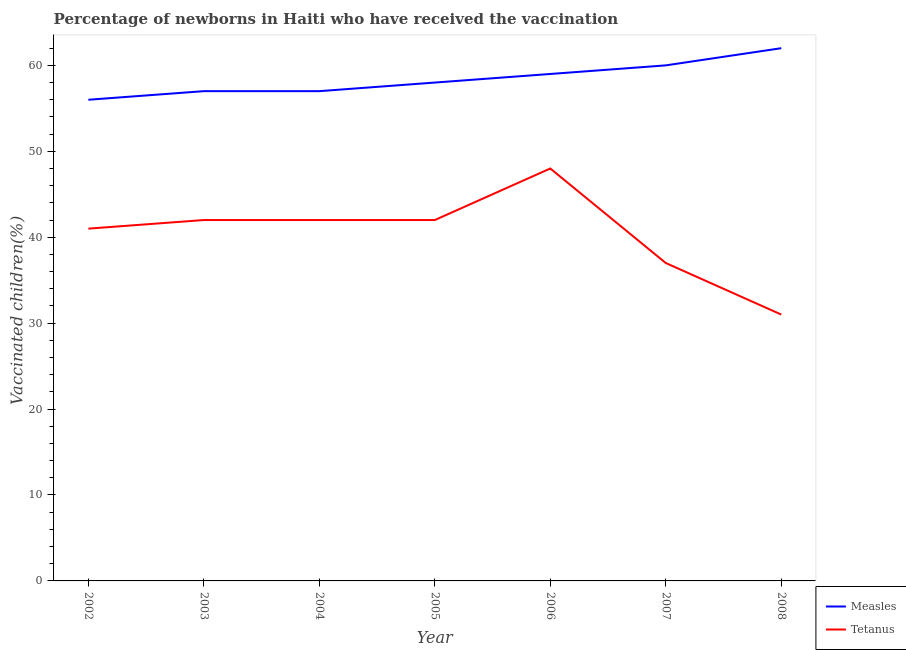How many different coloured lines are there?
Keep it short and to the point. 2. Does the line corresponding to percentage of newborns who received vaccination for measles intersect with the line corresponding to percentage of newborns who received vaccination for tetanus?
Offer a very short reply. No. What is the percentage of newborns who received vaccination for tetanus in 2002?
Your response must be concise. 41. Across all years, what is the maximum percentage of newborns who received vaccination for measles?
Give a very brief answer. 62. Across all years, what is the minimum percentage of newborns who received vaccination for measles?
Make the answer very short. 56. In which year was the percentage of newborns who received vaccination for measles minimum?
Provide a succinct answer. 2002. What is the total percentage of newborns who received vaccination for measles in the graph?
Give a very brief answer. 409. What is the difference between the percentage of newborns who received vaccination for measles in 2002 and that in 2006?
Your response must be concise. -3. What is the difference between the percentage of newborns who received vaccination for measles in 2004 and the percentage of newborns who received vaccination for tetanus in 2003?
Ensure brevity in your answer.  15. What is the average percentage of newborns who received vaccination for tetanus per year?
Offer a very short reply. 40.43. In the year 2002, what is the difference between the percentage of newborns who received vaccination for measles and percentage of newborns who received vaccination for tetanus?
Ensure brevity in your answer.  15. In how many years, is the percentage of newborns who received vaccination for measles greater than 22 %?
Make the answer very short. 7. What is the ratio of the percentage of newborns who received vaccination for tetanus in 2003 to that in 2004?
Offer a very short reply. 1. Is the percentage of newborns who received vaccination for measles in 2003 less than that in 2008?
Your answer should be compact. Yes. Is the difference between the percentage of newborns who received vaccination for tetanus in 2002 and 2007 greater than the difference between the percentage of newborns who received vaccination for measles in 2002 and 2007?
Make the answer very short. Yes. What is the difference between the highest and the lowest percentage of newborns who received vaccination for tetanus?
Give a very brief answer. 17. In how many years, is the percentage of newborns who received vaccination for measles greater than the average percentage of newborns who received vaccination for measles taken over all years?
Your response must be concise. 3. Is the sum of the percentage of newborns who received vaccination for tetanus in 2003 and 2005 greater than the maximum percentage of newborns who received vaccination for measles across all years?
Ensure brevity in your answer.  Yes. Does the percentage of newborns who received vaccination for measles monotonically increase over the years?
Offer a terse response. No. Is the percentage of newborns who received vaccination for measles strictly greater than the percentage of newborns who received vaccination for tetanus over the years?
Make the answer very short. Yes. How many lines are there?
Your response must be concise. 2. How many years are there in the graph?
Offer a very short reply. 7. Does the graph contain any zero values?
Offer a very short reply. No. How many legend labels are there?
Offer a terse response. 2. What is the title of the graph?
Your response must be concise. Percentage of newborns in Haiti who have received the vaccination. What is the label or title of the Y-axis?
Give a very brief answer. Vaccinated children(%)
. What is the Vaccinated children(%)
 in Measles in 2002?
Make the answer very short. 56. What is the Vaccinated children(%)
 of Tetanus in 2002?
Offer a terse response. 41. What is the Vaccinated children(%)
 in Measles in 2004?
Offer a very short reply. 57. What is the Vaccinated children(%)
 in Tetanus in 2004?
Keep it short and to the point. 42. What is the Vaccinated children(%)
 of Measles in 2005?
Offer a very short reply. 58. What is the Vaccinated children(%)
 in Tetanus in 2005?
Ensure brevity in your answer.  42. What is the Vaccinated children(%)
 of Tetanus in 2006?
Offer a very short reply. 48. What is the Vaccinated children(%)
 in Measles in 2007?
Offer a terse response. 60. What is the Vaccinated children(%)
 in Tetanus in 2007?
Give a very brief answer. 37. Across all years, what is the minimum Vaccinated children(%)
 of Measles?
Provide a short and direct response. 56. What is the total Vaccinated children(%)
 in Measles in the graph?
Keep it short and to the point. 409. What is the total Vaccinated children(%)
 in Tetanus in the graph?
Provide a succinct answer. 283. What is the difference between the Vaccinated children(%)
 in Tetanus in 2002 and that in 2003?
Make the answer very short. -1. What is the difference between the Vaccinated children(%)
 in Measles in 2002 and that in 2004?
Your answer should be compact. -1. What is the difference between the Vaccinated children(%)
 of Tetanus in 2002 and that in 2005?
Keep it short and to the point. -1. What is the difference between the Vaccinated children(%)
 of Tetanus in 2002 and that in 2006?
Keep it short and to the point. -7. What is the difference between the Vaccinated children(%)
 of Tetanus in 2002 and that in 2007?
Make the answer very short. 4. What is the difference between the Vaccinated children(%)
 in Measles in 2002 and that in 2008?
Provide a short and direct response. -6. What is the difference between the Vaccinated children(%)
 in Measles in 2003 and that in 2004?
Your answer should be very brief. 0. What is the difference between the Vaccinated children(%)
 of Measles in 2003 and that in 2005?
Give a very brief answer. -1. What is the difference between the Vaccinated children(%)
 of Tetanus in 2003 and that in 2005?
Offer a very short reply. 0. What is the difference between the Vaccinated children(%)
 of Measles in 2003 and that in 2006?
Keep it short and to the point. -2. What is the difference between the Vaccinated children(%)
 in Tetanus in 2003 and that in 2006?
Provide a short and direct response. -6. What is the difference between the Vaccinated children(%)
 in Measles in 2003 and that in 2007?
Provide a short and direct response. -3. What is the difference between the Vaccinated children(%)
 in Tetanus in 2004 and that in 2005?
Provide a short and direct response. 0. What is the difference between the Vaccinated children(%)
 in Measles in 2004 and that in 2006?
Your response must be concise. -2. What is the difference between the Vaccinated children(%)
 of Measles in 2004 and that in 2008?
Keep it short and to the point. -5. What is the difference between the Vaccinated children(%)
 in Tetanus in 2004 and that in 2008?
Offer a very short reply. 11. What is the difference between the Vaccinated children(%)
 in Tetanus in 2005 and that in 2006?
Provide a succinct answer. -6. What is the difference between the Vaccinated children(%)
 of Measles in 2005 and that in 2007?
Keep it short and to the point. -2. What is the difference between the Vaccinated children(%)
 in Tetanus in 2005 and that in 2007?
Provide a succinct answer. 5. What is the difference between the Vaccinated children(%)
 of Tetanus in 2005 and that in 2008?
Offer a terse response. 11. What is the difference between the Vaccinated children(%)
 of Measles in 2006 and that in 2007?
Offer a terse response. -1. What is the difference between the Vaccinated children(%)
 in Measles in 2007 and that in 2008?
Ensure brevity in your answer.  -2. What is the difference between the Vaccinated children(%)
 in Tetanus in 2007 and that in 2008?
Ensure brevity in your answer.  6. What is the difference between the Vaccinated children(%)
 of Measles in 2002 and the Vaccinated children(%)
 of Tetanus in 2003?
Provide a short and direct response. 14. What is the difference between the Vaccinated children(%)
 of Measles in 2002 and the Vaccinated children(%)
 of Tetanus in 2004?
Offer a terse response. 14. What is the difference between the Vaccinated children(%)
 of Measles in 2002 and the Vaccinated children(%)
 of Tetanus in 2005?
Ensure brevity in your answer.  14. What is the difference between the Vaccinated children(%)
 of Measles in 2002 and the Vaccinated children(%)
 of Tetanus in 2006?
Give a very brief answer. 8. What is the difference between the Vaccinated children(%)
 in Measles in 2002 and the Vaccinated children(%)
 in Tetanus in 2008?
Your answer should be compact. 25. What is the difference between the Vaccinated children(%)
 of Measles in 2003 and the Vaccinated children(%)
 of Tetanus in 2004?
Your response must be concise. 15. What is the difference between the Vaccinated children(%)
 in Measles in 2003 and the Vaccinated children(%)
 in Tetanus in 2005?
Your response must be concise. 15. What is the difference between the Vaccinated children(%)
 of Measles in 2003 and the Vaccinated children(%)
 of Tetanus in 2006?
Keep it short and to the point. 9. What is the difference between the Vaccinated children(%)
 in Measles in 2003 and the Vaccinated children(%)
 in Tetanus in 2007?
Provide a succinct answer. 20. What is the difference between the Vaccinated children(%)
 in Measles in 2003 and the Vaccinated children(%)
 in Tetanus in 2008?
Make the answer very short. 26. What is the difference between the Vaccinated children(%)
 in Measles in 2004 and the Vaccinated children(%)
 in Tetanus in 2005?
Ensure brevity in your answer.  15. What is the difference between the Vaccinated children(%)
 of Measles in 2004 and the Vaccinated children(%)
 of Tetanus in 2006?
Your response must be concise. 9. What is the difference between the Vaccinated children(%)
 of Measles in 2004 and the Vaccinated children(%)
 of Tetanus in 2008?
Keep it short and to the point. 26. What is the difference between the Vaccinated children(%)
 of Measles in 2005 and the Vaccinated children(%)
 of Tetanus in 2006?
Provide a succinct answer. 10. What is the difference between the Vaccinated children(%)
 in Measles in 2006 and the Vaccinated children(%)
 in Tetanus in 2008?
Provide a short and direct response. 28. What is the average Vaccinated children(%)
 of Measles per year?
Provide a succinct answer. 58.43. What is the average Vaccinated children(%)
 in Tetanus per year?
Offer a very short reply. 40.43. In the year 2003, what is the difference between the Vaccinated children(%)
 of Measles and Vaccinated children(%)
 of Tetanus?
Your answer should be compact. 15. In the year 2005, what is the difference between the Vaccinated children(%)
 of Measles and Vaccinated children(%)
 of Tetanus?
Provide a short and direct response. 16. In the year 2006, what is the difference between the Vaccinated children(%)
 of Measles and Vaccinated children(%)
 of Tetanus?
Offer a very short reply. 11. What is the ratio of the Vaccinated children(%)
 in Measles in 2002 to that in 2003?
Keep it short and to the point. 0.98. What is the ratio of the Vaccinated children(%)
 of Tetanus in 2002 to that in 2003?
Give a very brief answer. 0.98. What is the ratio of the Vaccinated children(%)
 in Measles in 2002 to that in 2004?
Give a very brief answer. 0.98. What is the ratio of the Vaccinated children(%)
 of Tetanus in 2002 to that in 2004?
Make the answer very short. 0.98. What is the ratio of the Vaccinated children(%)
 of Measles in 2002 to that in 2005?
Provide a succinct answer. 0.97. What is the ratio of the Vaccinated children(%)
 of Tetanus in 2002 to that in 2005?
Make the answer very short. 0.98. What is the ratio of the Vaccinated children(%)
 of Measles in 2002 to that in 2006?
Keep it short and to the point. 0.95. What is the ratio of the Vaccinated children(%)
 in Tetanus in 2002 to that in 2006?
Ensure brevity in your answer.  0.85. What is the ratio of the Vaccinated children(%)
 in Tetanus in 2002 to that in 2007?
Ensure brevity in your answer.  1.11. What is the ratio of the Vaccinated children(%)
 in Measles in 2002 to that in 2008?
Give a very brief answer. 0.9. What is the ratio of the Vaccinated children(%)
 in Tetanus in 2002 to that in 2008?
Give a very brief answer. 1.32. What is the ratio of the Vaccinated children(%)
 of Measles in 2003 to that in 2004?
Provide a short and direct response. 1. What is the ratio of the Vaccinated children(%)
 of Tetanus in 2003 to that in 2004?
Keep it short and to the point. 1. What is the ratio of the Vaccinated children(%)
 of Measles in 2003 to that in 2005?
Offer a very short reply. 0.98. What is the ratio of the Vaccinated children(%)
 of Tetanus in 2003 to that in 2005?
Make the answer very short. 1. What is the ratio of the Vaccinated children(%)
 in Measles in 2003 to that in 2006?
Offer a very short reply. 0.97. What is the ratio of the Vaccinated children(%)
 in Tetanus in 2003 to that in 2007?
Offer a terse response. 1.14. What is the ratio of the Vaccinated children(%)
 in Measles in 2003 to that in 2008?
Your response must be concise. 0.92. What is the ratio of the Vaccinated children(%)
 of Tetanus in 2003 to that in 2008?
Your answer should be very brief. 1.35. What is the ratio of the Vaccinated children(%)
 of Measles in 2004 to that in 2005?
Ensure brevity in your answer.  0.98. What is the ratio of the Vaccinated children(%)
 of Measles in 2004 to that in 2006?
Provide a short and direct response. 0.97. What is the ratio of the Vaccinated children(%)
 in Tetanus in 2004 to that in 2006?
Your response must be concise. 0.88. What is the ratio of the Vaccinated children(%)
 of Tetanus in 2004 to that in 2007?
Provide a short and direct response. 1.14. What is the ratio of the Vaccinated children(%)
 in Measles in 2004 to that in 2008?
Your answer should be very brief. 0.92. What is the ratio of the Vaccinated children(%)
 in Tetanus in 2004 to that in 2008?
Make the answer very short. 1.35. What is the ratio of the Vaccinated children(%)
 in Measles in 2005 to that in 2006?
Your response must be concise. 0.98. What is the ratio of the Vaccinated children(%)
 of Measles in 2005 to that in 2007?
Provide a short and direct response. 0.97. What is the ratio of the Vaccinated children(%)
 in Tetanus in 2005 to that in 2007?
Your response must be concise. 1.14. What is the ratio of the Vaccinated children(%)
 of Measles in 2005 to that in 2008?
Offer a terse response. 0.94. What is the ratio of the Vaccinated children(%)
 in Tetanus in 2005 to that in 2008?
Keep it short and to the point. 1.35. What is the ratio of the Vaccinated children(%)
 in Measles in 2006 to that in 2007?
Make the answer very short. 0.98. What is the ratio of the Vaccinated children(%)
 of Tetanus in 2006 to that in 2007?
Your answer should be very brief. 1.3. What is the ratio of the Vaccinated children(%)
 of Measles in 2006 to that in 2008?
Your answer should be very brief. 0.95. What is the ratio of the Vaccinated children(%)
 of Tetanus in 2006 to that in 2008?
Keep it short and to the point. 1.55. What is the ratio of the Vaccinated children(%)
 of Tetanus in 2007 to that in 2008?
Make the answer very short. 1.19. 